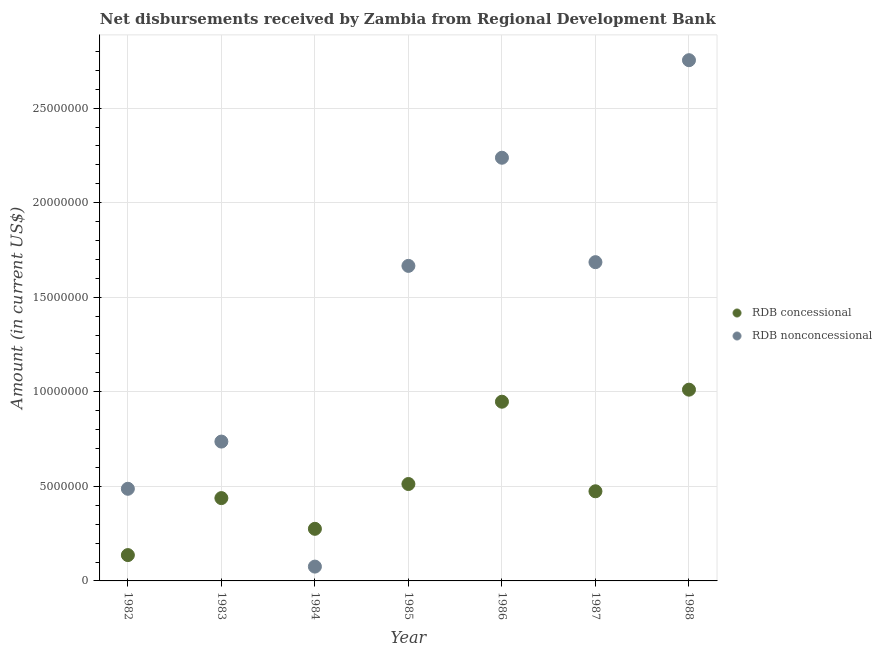How many different coloured dotlines are there?
Your response must be concise. 2. What is the net concessional disbursements from rdb in 1986?
Make the answer very short. 9.48e+06. Across all years, what is the maximum net non concessional disbursements from rdb?
Make the answer very short. 2.75e+07. Across all years, what is the minimum net non concessional disbursements from rdb?
Provide a succinct answer. 7.57e+05. In which year was the net non concessional disbursements from rdb maximum?
Keep it short and to the point. 1988. What is the total net concessional disbursements from rdb in the graph?
Keep it short and to the point. 3.80e+07. What is the difference between the net concessional disbursements from rdb in 1983 and that in 1984?
Your response must be concise. 1.62e+06. What is the difference between the net concessional disbursements from rdb in 1985 and the net non concessional disbursements from rdb in 1988?
Make the answer very short. -2.24e+07. What is the average net non concessional disbursements from rdb per year?
Keep it short and to the point. 1.38e+07. In the year 1985, what is the difference between the net concessional disbursements from rdb and net non concessional disbursements from rdb?
Offer a very short reply. -1.15e+07. In how many years, is the net non concessional disbursements from rdb greater than 17000000 US$?
Your response must be concise. 2. What is the ratio of the net concessional disbursements from rdb in 1983 to that in 1984?
Your answer should be compact. 1.59. Is the difference between the net concessional disbursements from rdb in 1983 and 1984 greater than the difference between the net non concessional disbursements from rdb in 1983 and 1984?
Offer a terse response. No. What is the difference between the highest and the second highest net concessional disbursements from rdb?
Provide a succinct answer. 6.37e+05. What is the difference between the highest and the lowest net non concessional disbursements from rdb?
Your answer should be compact. 2.68e+07. In how many years, is the net non concessional disbursements from rdb greater than the average net non concessional disbursements from rdb taken over all years?
Your answer should be compact. 4. Does the net non concessional disbursements from rdb monotonically increase over the years?
Provide a succinct answer. No. Is the net non concessional disbursements from rdb strictly greater than the net concessional disbursements from rdb over the years?
Your response must be concise. No. How many dotlines are there?
Offer a very short reply. 2. How many years are there in the graph?
Your response must be concise. 7. What is the difference between two consecutive major ticks on the Y-axis?
Give a very brief answer. 5.00e+06. Are the values on the major ticks of Y-axis written in scientific E-notation?
Your answer should be compact. No. Does the graph contain grids?
Keep it short and to the point. Yes. Where does the legend appear in the graph?
Your answer should be very brief. Center right. What is the title of the graph?
Ensure brevity in your answer.  Net disbursements received by Zambia from Regional Development Bank. What is the label or title of the X-axis?
Your answer should be very brief. Year. What is the label or title of the Y-axis?
Offer a terse response. Amount (in current US$). What is the Amount (in current US$) in RDB concessional in 1982?
Your response must be concise. 1.37e+06. What is the Amount (in current US$) of RDB nonconcessional in 1982?
Keep it short and to the point. 4.87e+06. What is the Amount (in current US$) of RDB concessional in 1983?
Offer a terse response. 4.38e+06. What is the Amount (in current US$) of RDB nonconcessional in 1983?
Provide a succinct answer. 7.37e+06. What is the Amount (in current US$) in RDB concessional in 1984?
Provide a short and direct response. 2.76e+06. What is the Amount (in current US$) of RDB nonconcessional in 1984?
Your answer should be compact. 7.57e+05. What is the Amount (in current US$) in RDB concessional in 1985?
Your answer should be compact. 5.12e+06. What is the Amount (in current US$) of RDB nonconcessional in 1985?
Your answer should be very brief. 1.67e+07. What is the Amount (in current US$) of RDB concessional in 1986?
Offer a terse response. 9.48e+06. What is the Amount (in current US$) in RDB nonconcessional in 1986?
Make the answer very short. 2.24e+07. What is the Amount (in current US$) of RDB concessional in 1987?
Offer a terse response. 4.74e+06. What is the Amount (in current US$) in RDB nonconcessional in 1987?
Ensure brevity in your answer.  1.69e+07. What is the Amount (in current US$) in RDB concessional in 1988?
Provide a short and direct response. 1.01e+07. What is the Amount (in current US$) in RDB nonconcessional in 1988?
Keep it short and to the point. 2.75e+07. Across all years, what is the maximum Amount (in current US$) in RDB concessional?
Give a very brief answer. 1.01e+07. Across all years, what is the maximum Amount (in current US$) of RDB nonconcessional?
Provide a short and direct response. 2.75e+07. Across all years, what is the minimum Amount (in current US$) of RDB concessional?
Provide a short and direct response. 1.37e+06. Across all years, what is the minimum Amount (in current US$) of RDB nonconcessional?
Provide a succinct answer. 7.57e+05. What is the total Amount (in current US$) of RDB concessional in the graph?
Your answer should be compact. 3.80e+07. What is the total Amount (in current US$) in RDB nonconcessional in the graph?
Provide a succinct answer. 9.64e+07. What is the difference between the Amount (in current US$) of RDB concessional in 1982 and that in 1983?
Offer a terse response. -3.01e+06. What is the difference between the Amount (in current US$) of RDB nonconcessional in 1982 and that in 1983?
Provide a succinct answer. -2.50e+06. What is the difference between the Amount (in current US$) of RDB concessional in 1982 and that in 1984?
Your answer should be very brief. -1.39e+06. What is the difference between the Amount (in current US$) in RDB nonconcessional in 1982 and that in 1984?
Your answer should be compact. 4.12e+06. What is the difference between the Amount (in current US$) in RDB concessional in 1982 and that in 1985?
Offer a terse response. -3.76e+06. What is the difference between the Amount (in current US$) in RDB nonconcessional in 1982 and that in 1985?
Provide a succinct answer. -1.18e+07. What is the difference between the Amount (in current US$) in RDB concessional in 1982 and that in 1986?
Provide a succinct answer. -8.11e+06. What is the difference between the Amount (in current US$) of RDB nonconcessional in 1982 and that in 1986?
Offer a very short reply. -1.75e+07. What is the difference between the Amount (in current US$) in RDB concessional in 1982 and that in 1987?
Offer a very short reply. -3.37e+06. What is the difference between the Amount (in current US$) in RDB nonconcessional in 1982 and that in 1987?
Offer a very short reply. -1.20e+07. What is the difference between the Amount (in current US$) in RDB concessional in 1982 and that in 1988?
Ensure brevity in your answer.  -8.75e+06. What is the difference between the Amount (in current US$) in RDB nonconcessional in 1982 and that in 1988?
Make the answer very short. -2.27e+07. What is the difference between the Amount (in current US$) of RDB concessional in 1983 and that in 1984?
Keep it short and to the point. 1.62e+06. What is the difference between the Amount (in current US$) in RDB nonconcessional in 1983 and that in 1984?
Provide a short and direct response. 6.61e+06. What is the difference between the Amount (in current US$) in RDB concessional in 1983 and that in 1985?
Your answer should be compact. -7.45e+05. What is the difference between the Amount (in current US$) of RDB nonconcessional in 1983 and that in 1985?
Ensure brevity in your answer.  -9.29e+06. What is the difference between the Amount (in current US$) of RDB concessional in 1983 and that in 1986?
Your answer should be compact. -5.10e+06. What is the difference between the Amount (in current US$) in RDB nonconcessional in 1983 and that in 1986?
Keep it short and to the point. -1.50e+07. What is the difference between the Amount (in current US$) in RDB concessional in 1983 and that in 1987?
Your answer should be very brief. -3.61e+05. What is the difference between the Amount (in current US$) of RDB nonconcessional in 1983 and that in 1987?
Offer a very short reply. -9.49e+06. What is the difference between the Amount (in current US$) in RDB concessional in 1983 and that in 1988?
Provide a succinct answer. -5.73e+06. What is the difference between the Amount (in current US$) of RDB nonconcessional in 1983 and that in 1988?
Your answer should be very brief. -2.02e+07. What is the difference between the Amount (in current US$) of RDB concessional in 1984 and that in 1985?
Give a very brief answer. -2.37e+06. What is the difference between the Amount (in current US$) of RDB nonconcessional in 1984 and that in 1985?
Provide a succinct answer. -1.59e+07. What is the difference between the Amount (in current US$) in RDB concessional in 1984 and that in 1986?
Provide a short and direct response. -6.72e+06. What is the difference between the Amount (in current US$) in RDB nonconcessional in 1984 and that in 1986?
Your answer should be compact. -2.16e+07. What is the difference between the Amount (in current US$) of RDB concessional in 1984 and that in 1987?
Make the answer very short. -1.98e+06. What is the difference between the Amount (in current US$) of RDB nonconcessional in 1984 and that in 1987?
Provide a succinct answer. -1.61e+07. What is the difference between the Amount (in current US$) in RDB concessional in 1984 and that in 1988?
Your answer should be compact. -7.36e+06. What is the difference between the Amount (in current US$) of RDB nonconcessional in 1984 and that in 1988?
Keep it short and to the point. -2.68e+07. What is the difference between the Amount (in current US$) in RDB concessional in 1985 and that in 1986?
Ensure brevity in your answer.  -4.35e+06. What is the difference between the Amount (in current US$) of RDB nonconcessional in 1985 and that in 1986?
Keep it short and to the point. -5.72e+06. What is the difference between the Amount (in current US$) in RDB concessional in 1985 and that in 1987?
Ensure brevity in your answer.  3.84e+05. What is the difference between the Amount (in current US$) in RDB nonconcessional in 1985 and that in 1987?
Your answer should be compact. -1.97e+05. What is the difference between the Amount (in current US$) of RDB concessional in 1985 and that in 1988?
Your answer should be compact. -4.99e+06. What is the difference between the Amount (in current US$) in RDB nonconcessional in 1985 and that in 1988?
Provide a short and direct response. -1.09e+07. What is the difference between the Amount (in current US$) of RDB concessional in 1986 and that in 1987?
Ensure brevity in your answer.  4.74e+06. What is the difference between the Amount (in current US$) in RDB nonconcessional in 1986 and that in 1987?
Provide a short and direct response. 5.52e+06. What is the difference between the Amount (in current US$) of RDB concessional in 1986 and that in 1988?
Provide a succinct answer. -6.37e+05. What is the difference between the Amount (in current US$) in RDB nonconcessional in 1986 and that in 1988?
Ensure brevity in your answer.  -5.16e+06. What is the difference between the Amount (in current US$) in RDB concessional in 1987 and that in 1988?
Offer a terse response. -5.37e+06. What is the difference between the Amount (in current US$) in RDB nonconcessional in 1987 and that in 1988?
Give a very brief answer. -1.07e+07. What is the difference between the Amount (in current US$) of RDB concessional in 1982 and the Amount (in current US$) of RDB nonconcessional in 1983?
Give a very brief answer. -6.00e+06. What is the difference between the Amount (in current US$) of RDB concessional in 1982 and the Amount (in current US$) of RDB nonconcessional in 1984?
Keep it short and to the point. 6.09e+05. What is the difference between the Amount (in current US$) in RDB concessional in 1982 and the Amount (in current US$) in RDB nonconcessional in 1985?
Your response must be concise. -1.53e+07. What is the difference between the Amount (in current US$) of RDB concessional in 1982 and the Amount (in current US$) of RDB nonconcessional in 1986?
Provide a short and direct response. -2.10e+07. What is the difference between the Amount (in current US$) of RDB concessional in 1982 and the Amount (in current US$) of RDB nonconcessional in 1987?
Give a very brief answer. -1.55e+07. What is the difference between the Amount (in current US$) in RDB concessional in 1982 and the Amount (in current US$) in RDB nonconcessional in 1988?
Your response must be concise. -2.62e+07. What is the difference between the Amount (in current US$) of RDB concessional in 1983 and the Amount (in current US$) of RDB nonconcessional in 1984?
Give a very brief answer. 3.62e+06. What is the difference between the Amount (in current US$) of RDB concessional in 1983 and the Amount (in current US$) of RDB nonconcessional in 1985?
Your answer should be very brief. -1.23e+07. What is the difference between the Amount (in current US$) of RDB concessional in 1983 and the Amount (in current US$) of RDB nonconcessional in 1986?
Make the answer very short. -1.80e+07. What is the difference between the Amount (in current US$) of RDB concessional in 1983 and the Amount (in current US$) of RDB nonconcessional in 1987?
Provide a short and direct response. -1.25e+07. What is the difference between the Amount (in current US$) of RDB concessional in 1983 and the Amount (in current US$) of RDB nonconcessional in 1988?
Your answer should be very brief. -2.32e+07. What is the difference between the Amount (in current US$) in RDB concessional in 1984 and the Amount (in current US$) in RDB nonconcessional in 1985?
Provide a succinct answer. -1.39e+07. What is the difference between the Amount (in current US$) in RDB concessional in 1984 and the Amount (in current US$) in RDB nonconcessional in 1986?
Ensure brevity in your answer.  -1.96e+07. What is the difference between the Amount (in current US$) in RDB concessional in 1984 and the Amount (in current US$) in RDB nonconcessional in 1987?
Provide a short and direct response. -1.41e+07. What is the difference between the Amount (in current US$) of RDB concessional in 1984 and the Amount (in current US$) of RDB nonconcessional in 1988?
Your answer should be compact. -2.48e+07. What is the difference between the Amount (in current US$) of RDB concessional in 1985 and the Amount (in current US$) of RDB nonconcessional in 1986?
Ensure brevity in your answer.  -1.73e+07. What is the difference between the Amount (in current US$) of RDB concessional in 1985 and the Amount (in current US$) of RDB nonconcessional in 1987?
Provide a succinct answer. -1.17e+07. What is the difference between the Amount (in current US$) of RDB concessional in 1985 and the Amount (in current US$) of RDB nonconcessional in 1988?
Provide a short and direct response. -2.24e+07. What is the difference between the Amount (in current US$) of RDB concessional in 1986 and the Amount (in current US$) of RDB nonconcessional in 1987?
Provide a short and direct response. -7.38e+06. What is the difference between the Amount (in current US$) of RDB concessional in 1986 and the Amount (in current US$) of RDB nonconcessional in 1988?
Offer a very short reply. -1.81e+07. What is the difference between the Amount (in current US$) in RDB concessional in 1987 and the Amount (in current US$) in RDB nonconcessional in 1988?
Provide a short and direct response. -2.28e+07. What is the average Amount (in current US$) in RDB concessional per year?
Keep it short and to the point. 5.42e+06. What is the average Amount (in current US$) in RDB nonconcessional per year?
Ensure brevity in your answer.  1.38e+07. In the year 1982, what is the difference between the Amount (in current US$) of RDB concessional and Amount (in current US$) of RDB nonconcessional?
Your answer should be very brief. -3.51e+06. In the year 1983, what is the difference between the Amount (in current US$) in RDB concessional and Amount (in current US$) in RDB nonconcessional?
Offer a terse response. -2.99e+06. In the year 1984, what is the difference between the Amount (in current US$) of RDB concessional and Amount (in current US$) of RDB nonconcessional?
Your answer should be compact. 2.00e+06. In the year 1985, what is the difference between the Amount (in current US$) of RDB concessional and Amount (in current US$) of RDB nonconcessional?
Offer a terse response. -1.15e+07. In the year 1986, what is the difference between the Amount (in current US$) in RDB concessional and Amount (in current US$) in RDB nonconcessional?
Your answer should be very brief. -1.29e+07. In the year 1987, what is the difference between the Amount (in current US$) in RDB concessional and Amount (in current US$) in RDB nonconcessional?
Provide a succinct answer. -1.21e+07. In the year 1988, what is the difference between the Amount (in current US$) in RDB concessional and Amount (in current US$) in RDB nonconcessional?
Keep it short and to the point. -1.74e+07. What is the ratio of the Amount (in current US$) of RDB concessional in 1982 to that in 1983?
Offer a very short reply. 0.31. What is the ratio of the Amount (in current US$) of RDB nonconcessional in 1982 to that in 1983?
Give a very brief answer. 0.66. What is the ratio of the Amount (in current US$) of RDB concessional in 1982 to that in 1984?
Your answer should be very brief. 0.5. What is the ratio of the Amount (in current US$) in RDB nonconcessional in 1982 to that in 1984?
Your answer should be very brief. 6.44. What is the ratio of the Amount (in current US$) in RDB concessional in 1982 to that in 1985?
Offer a terse response. 0.27. What is the ratio of the Amount (in current US$) of RDB nonconcessional in 1982 to that in 1985?
Provide a short and direct response. 0.29. What is the ratio of the Amount (in current US$) in RDB concessional in 1982 to that in 1986?
Your answer should be very brief. 0.14. What is the ratio of the Amount (in current US$) of RDB nonconcessional in 1982 to that in 1986?
Your answer should be very brief. 0.22. What is the ratio of the Amount (in current US$) in RDB concessional in 1982 to that in 1987?
Provide a short and direct response. 0.29. What is the ratio of the Amount (in current US$) of RDB nonconcessional in 1982 to that in 1987?
Keep it short and to the point. 0.29. What is the ratio of the Amount (in current US$) of RDB concessional in 1982 to that in 1988?
Offer a very short reply. 0.14. What is the ratio of the Amount (in current US$) in RDB nonconcessional in 1982 to that in 1988?
Your answer should be compact. 0.18. What is the ratio of the Amount (in current US$) of RDB concessional in 1983 to that in 1984?
Offer a terse response. 1.59. What is the ratio of the Amount (in current US$) in RDB nonconcessional in 1983 to that in 1984?
Offer a very short reply. 9.73. What is the ratio of the Amount (in current US$) in RDB concessional in 1983 to that in 1985?
Offer a terse response. 0.85. What is the ratio of the Amount (in current US$) in RDB nonconcessional in 1983 to that in 1985?
Give a very brief answer. 0.44. What is the ratio of the Amount (in current US$) of RDB concessional in 1983 to that in 1986?
Give a very brief answer. 0.46. What is the ratio of the Amount (in current US$) in RDB nonconcessional in 1983 to that in 1986?
Ensure brevity in your answer.  0.33. What is the ratio of the Amount (in current US$) of RDB concessional in 1983 to that in 1987?
Keep it short and to the point. 0.92. What is the ratio of the Amount (in current US$) of RDB nonconcessional in 1983 to that in 1987?
Offer a terse response. 0.44. What is the ratio of the Amount (in current US$) of RDB concessional in 1983 to that in 1988?
Make the answer very short. 0.43. What is the ratio of the Amount (in current US$) in RDB nonconcessional in 1983 to that in 1988?
Provide a short and direct response. 0.27. What is the ratio of the Amount (in current US$) in RDB concessional in 1984 to that in 1985?
Your answer should be compact. 0.54. What is the ratio of the Amount (in current US$) in RDB nonconcessional in 1984 to that in 1985?
Provide a short and direct response. 0.05. What is the ratio of the Amount (in current US$) of RDB concessional in 1984 to that in 1986?
Provide a short and direct response. 0.29. What is the ratio of the Amount (in current US$) in RDB nonconcessional in 1984 to that in 1986?
Your answer should be very brief. 0.03. What is the ratio of the Amount (in current US$) of RDB concessional in 1984 to that in 1987?
Provide a succinct answer. 0.58. What is the ratio of the Amount (in current US$) in RDB nonconcessional in 1984 to that in 1987?
Offer a very short reply. 0.04. What is the ratio of the Amount (in current US$) in RDB concessional in 1984 to that in 1988?
Provide a succinct answer. 0.27. What is the ratio of the Amount (in current US$) in RDB nonconcessional in 1984 to that in 1988?
Keep it short and to the point. 0.03. What is the ratio of the Amount (in current US$) of RDB concessional in 1985 to that in 1986?
Your answer should be compact. 0.54. What is the ratio of the Amount (in current US$) of RDB nonconcessional in 1985 to that in 1986?
Provide a short and direct response. 0.74. What is the ratio of the Amount (in current US$) in RDB concessional in 1985 to that in 1987?
Give a very brief answer. 1.08. What is the ratio of the Amount (in current US$) in RDB nonconcessional in 1985 to that in 1987?
Offer a terse response. 0.99. What is the ratio of the Amount (in current US$) in RDB concessional in 1985 to that in 1988?
Ensure brevity in your answer.  0.51. What is the ratio of the Amount (in current US$) in RDB nonconcessional in 1985 to that in 1988?
Offer a terse response. 0.6. What is the ratio of the Amount (in current US$) of RDB concessional in 1986 to that in 1987?
Offer a very short reply. 2. What is the ratio of the Amount (in current US$) in RDB nonconcessional in 1986 to that in 1987?
Your answer should be very brief. 1.33. What is the ratio of the Amount (in current US$) in RDB concessional in 1986 to that in 1988?
Your answer should be very brief. 0.94. What is the ratio of the Amount (in current US$) in RDB nonconcessional in 1986 to that in 1988?
Ensure brevity in your answer.  0.81. What is the ratio of the Amount (in current US$) in RDB concessional in 1987 to that in 1988?
Offer a terse response. 0.47. What is the ratio of the Amount (in current US$) in RDB nonconcessional in 1987 to that in 1988?
Offer a very short reply. 0.61. What is the difference between the highest and the second highest Amount (in current US$) in RDB concessional?
Make the answer very short. 6.37e+05. What is the difference between the highest and the second highest Amount (in current US$) in RDB nonconcessional?
Offer a very short reply. 5.16e+06. What is the difference between the highest and the lowest Amount (in current US$) in RDB concessional?
Make the answer very short. 8.75e+06. What is the difference between the highest and the lowest Amount (in current US$) of RDB nonconcessional?
Your response must be concise. 2.68e+07. 